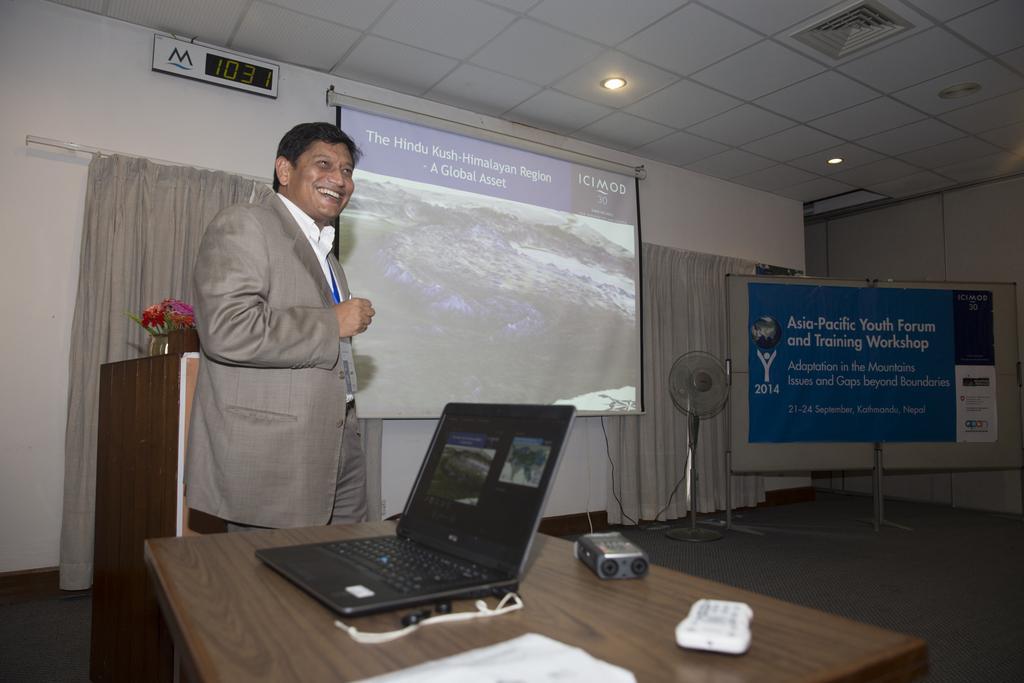Can you describe this image briefly? As we can see in the image there is a white color wall, curtain, screen, a man standing, banner, fan and on table there is a laptop, remote and paper. 